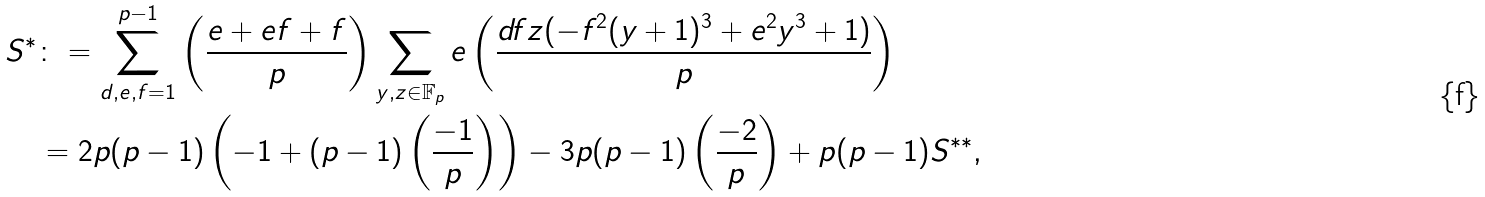Convert formula to latex. <formula><loc_0><loc_0><loc_500><loc_500>S ^ { * } & \colon = \sum _ { d , e , f = 1 } ^ { p - 1 } \left ( \frac { e + e f + f } { p } \right ) \sum _ { y , z \in \mathbb { F } _ { p } } e \left ( \frac { d f z ( - f ^ { 2 } ( y + 1 ) ^ { 3 } + e ^ { 2 } y ^ { 3 } + 1 ) } { p } \right ) \\ & = 2 p ( p - 1 ) \left ( - 1 + ( p - 1 ) \left ( \frac { - 1 } { p } \right ) \right ) - 3 p ( p - 1 ) \left ( \frac { - 2 } { p } \right ) + p ( p - 1 ) S ^ { * * } ,</formula> 